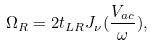Convert formula to latex. <formula><loc_0><loc_0><loc_500><loc_500>\Omega _ { R } = 2 t _ { L R } J _ { \nu } ( \frac { V _ { a c } } { \omega } ) ,</formula> 